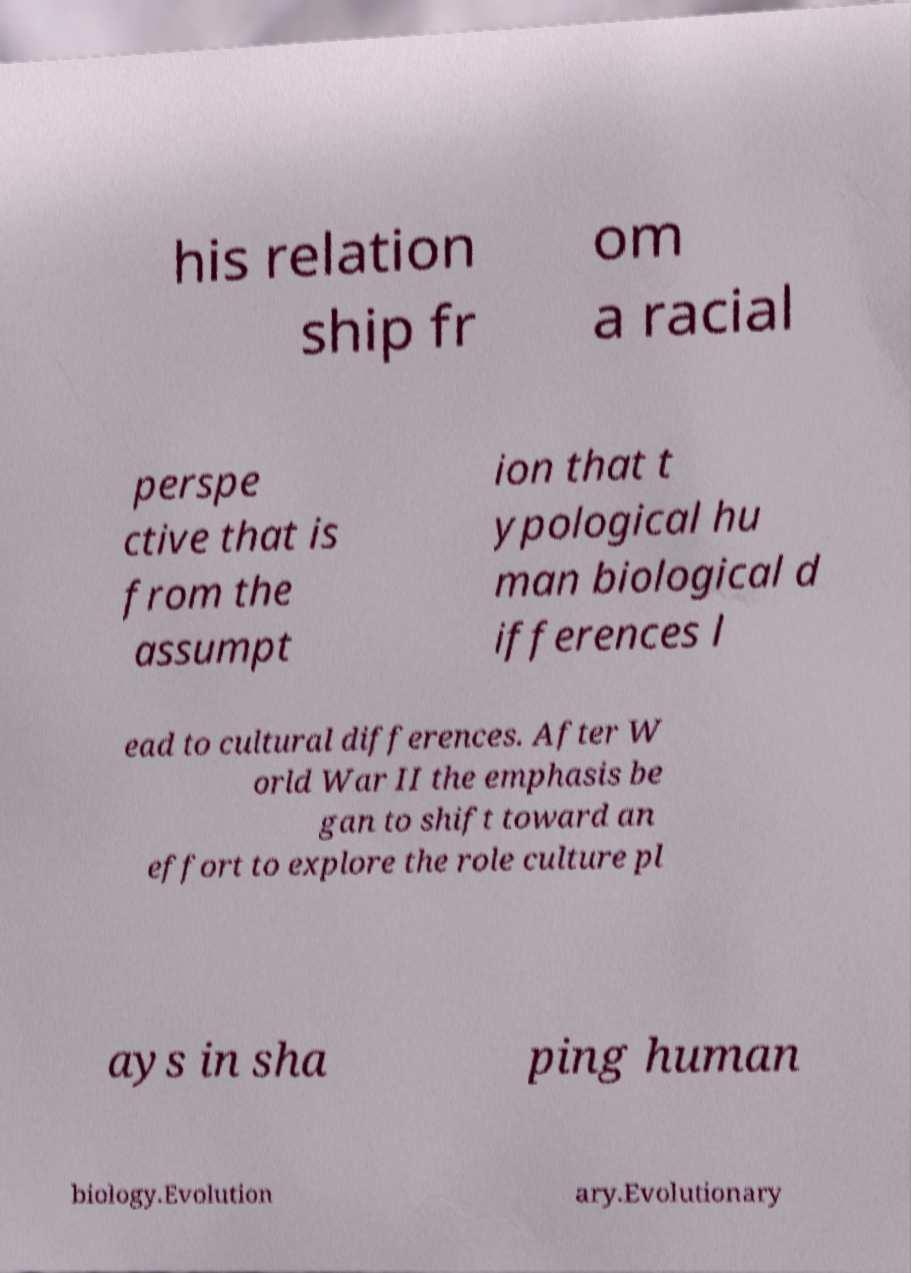What messages or text are displayed in this image? I need them in a readable, typed format. his relation ship fr om a racial perspe ctive that is from the assumpt ion that t ypological hu man biological d ifferences l ead to cultural differences. After W orld War II the emphasis be gan to shift toward an effort to explore the role culture pl ays in sha ping human biology.Evolution ary.Evolutionary 